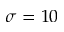<formula> <loc_0><loc_0><loc_500><loc_500>\sigma = 1 0</formula> 